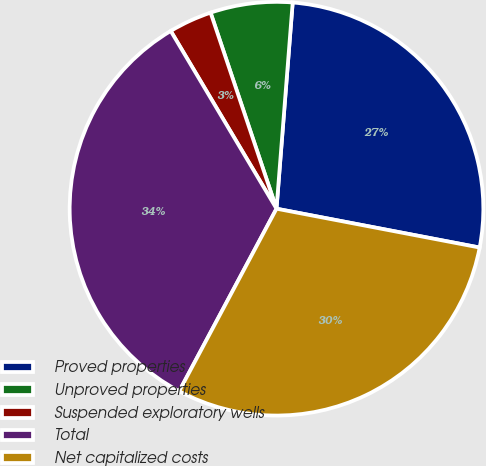<chart> <loc_0><loc_0><loc_500><loc_500><pie_chart><fcel>Proved properties<fcel>Unproved properties<fcel>Suspended exploratory wells<fcel>Total<fcel>Net capitalized costs<nl><fcel>26.76%<fcel>6.41%<fcel>3.38%<fcel>33.66%<fcel>29.79%<nl></chart> 